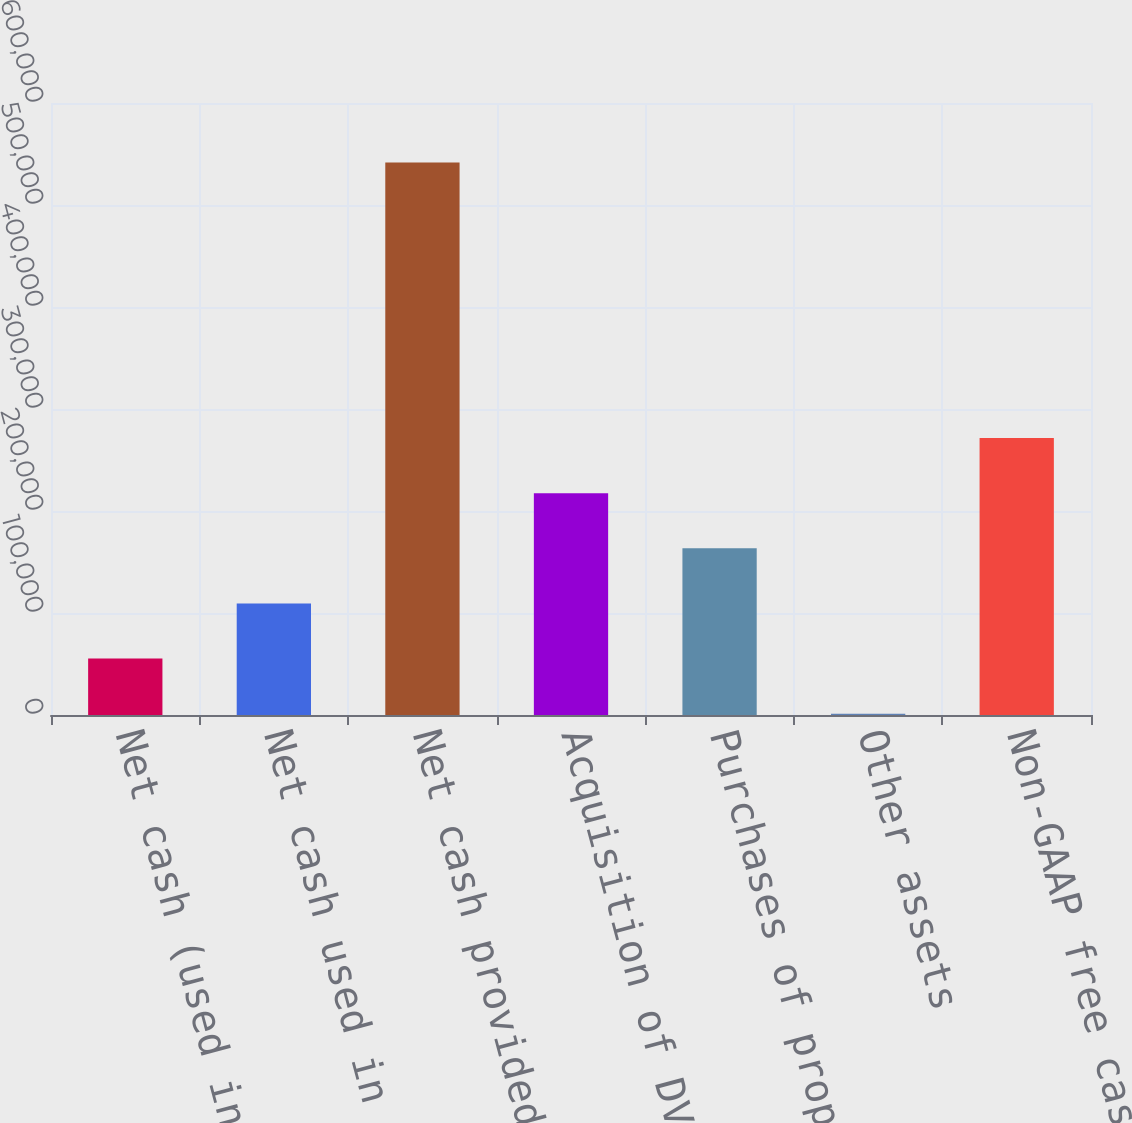<chart> <loc_0><loc_0><loc_500><loc_500><bar_chart><fcel>Net cash (used in) provided by<fcel>Net cash used in investing<fcel>Net cash provided by financing<fcel>Acquisition of DVD content<fcel>Purchases of property and<fcel>Other assets<fcel>Non-GAAP free cash flow<nl><fcel>55371.8<fcel>109410<fcel>541712<fcel>217485<fcel>163447<fcel>1334<fcel>271523<nl></chart> 